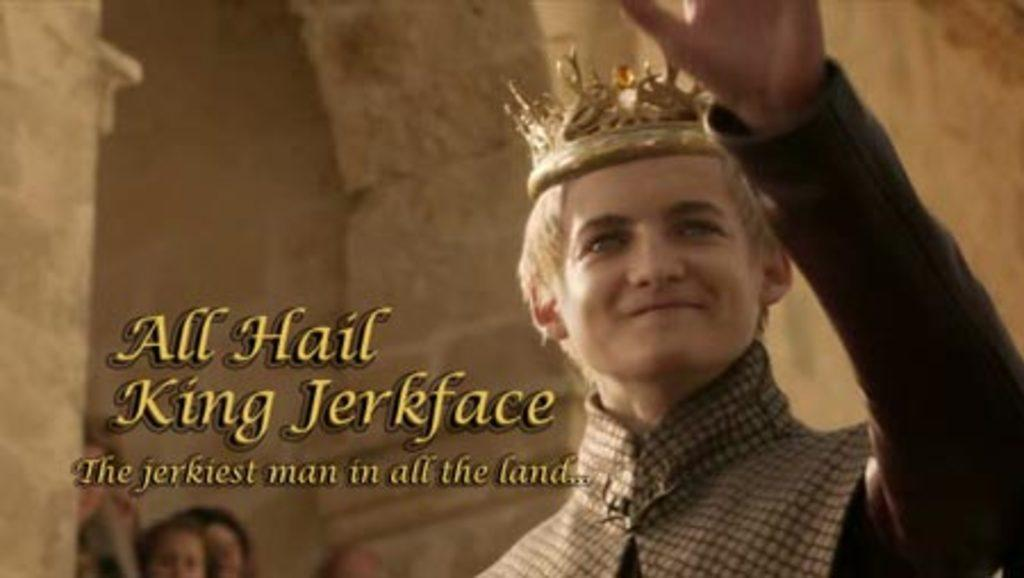Who is wearing a crown in the image? There is a person wearing a crown in the image. Where is the person with the crown located? The person with the crown is on the right side of the image. What can be seen on the left side of the image? There is text on the left side of the image. What is the background of the image? The background of the image is a wall. What else can be seen at the bottom left of the image? There are people's faces visible at the bottom left of the image. Is there a veil covering the person's face in the image? There is no veil covering the person's face in the image. What type of experience does the person with the crown have in the image? The image does not provide any information about the person's experience. 